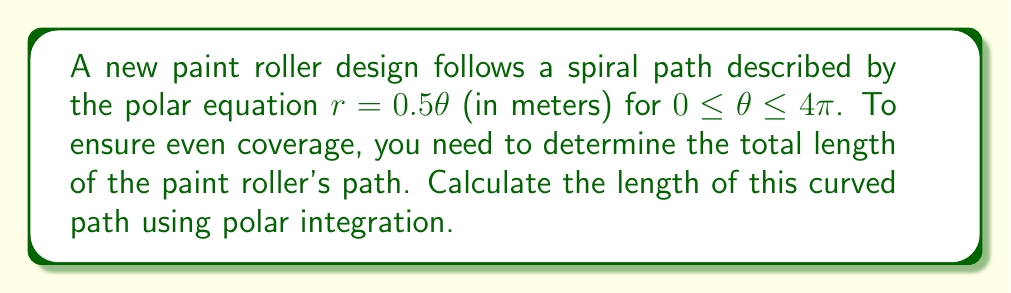Teach me how to tackle this problem. To find the length of a curved path in polar coordinates, we use the arc length formula:

$$ L = \int_{a}^{b} \sqrt{r^2 + \left(\frac{dr}{d\theta}\right)^2} d\theta $$

For our spiral path $r = 0.5\theta$, we need to follow these steps:

1) First, find $\frac{dr}{d\theta}$:
   $\frac{dr}{d\theta} = 0.5$

2) Substitute $r$ and $\frac{dr}{d\theta}$ into the formula:
   $$ L = \int_{0}^{4\pi} \sqrt{(0.5\theta)^2 + (0.5)^2} d\theta $$

3) Simplify under the square root:
   $$ L = \int_{0}^{4\pi} \sqrt{0.25\theta^2 + 0.25} d\theta $$
   $$ L = 0.5 \int_{0}^{4\pi} \sqrt{\theta^2 + 1} d\theta $$

4) This integral doesn't have an elementary antiderivative. We can solve it using the substitution $\theta = \sinh u$:

   $d\theta = \cosh u du$
   When $\theta = 0$, $u = 0$
   When $\theta = 4\pi$, $u = \sinh^{-1}(4\pi)$

   $$ L = 0.5 \int_{0}^{\sinh^{-1}(4\pi)} \sqrt{\sinh^2 u + 1} \cosh u du $$

5) Simplify using the identity $\sinh^2 u + 1 = \cosh^2 u$:
   $$ L = 0.5 \int_{0}^{\sinh^{-1}(4\pi)} \cosh^2 u du $$

6) Use the identity $\cosh^2 u = \frac{1}{2}(\cosh 2u + 1)$:
   $$ L = 0.25 \int_{0}^{\sinh^{-1}(4\pi)} (\cosh 2u + 1) du $$

7) Integrate:
   $$ L = 0.25 \left[\frac{1}{2}\sinh 2u + u\right]_{0}^{\sinh^{-1}(4\pi)} $$

8) Evaluate the limits:
   $$ L = 0.25 \left[\frac{1}{2}\sinh(2\sinh^{-1}(4\pi)) + \sinh^{-1}(4\pi)\right] $$

9) Simplify using the identity $\sinh(2\sinh^{-1}(x)) = 2x\sqrt{1+x^2}$:
   $$ L = 0.25 \left[4\pi\sqrt{1+(4\pi)^2} + \sinh^{-1}(4\pi)\right] $$

This is the exact solution. For a numerical approximation, we can evaluate this expression.
Answer: The exact length of the paint roller's path is:

$$ L = 0.25 \left[4\pi\sqrt{1+(4\pi)^2} + \sinh^{-1}(4\pi)\right] \approx 25.13 \text{ meters} $$ 